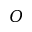<formula> <loc_0><loc_0><loc_500><loc_500>O</formula> 